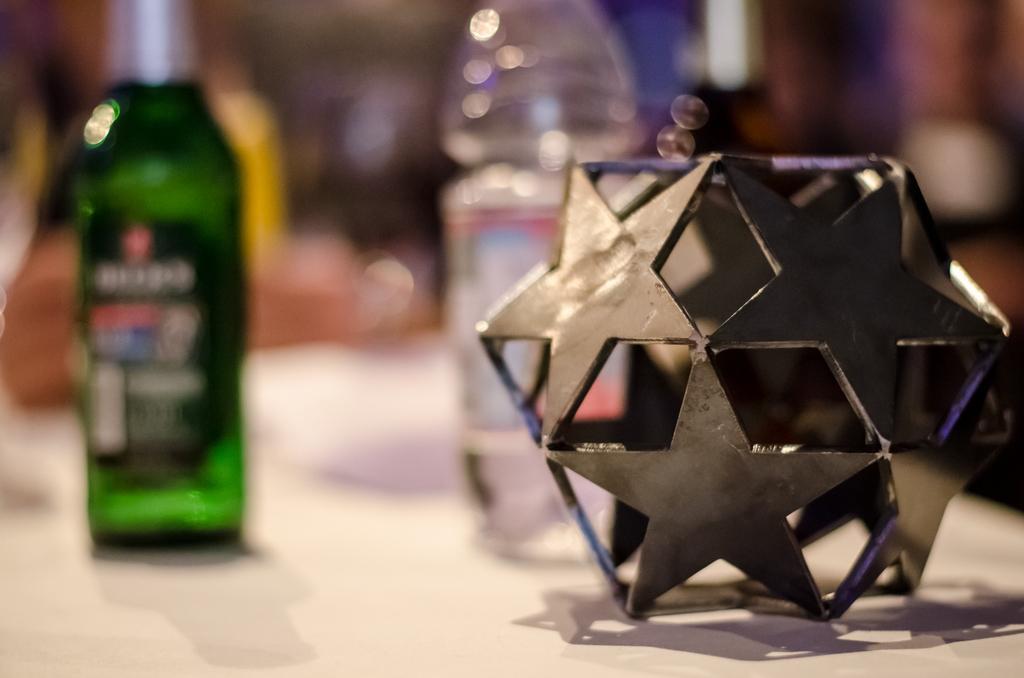How would you summarize this image in a sentence or two? Bottom of the image there is a table on the table there are two bottle and there is a product. 